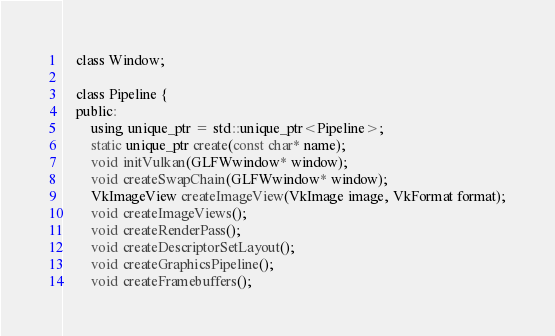Convert code to text. <code><loc_0><loc_0><loc_500><loc_500><_C_>    class Window;

    class Pipeline {
    public:
        using unique_ptr = std::unique_ptr<Pipeline>;
        static unique_ptr create(const char* name);
        void initVulkan(GLFWwindow* window);
        void createSwapChain(GLFWwindow* window);
        VkImageView createImageView(VkImage image, VkFormat format);
        void createImageViews();
        void createRenderPass();
        void createDescriptorSetLayout();
        void createGraphicsPipeline();
        void createFramebuffers();</code> 